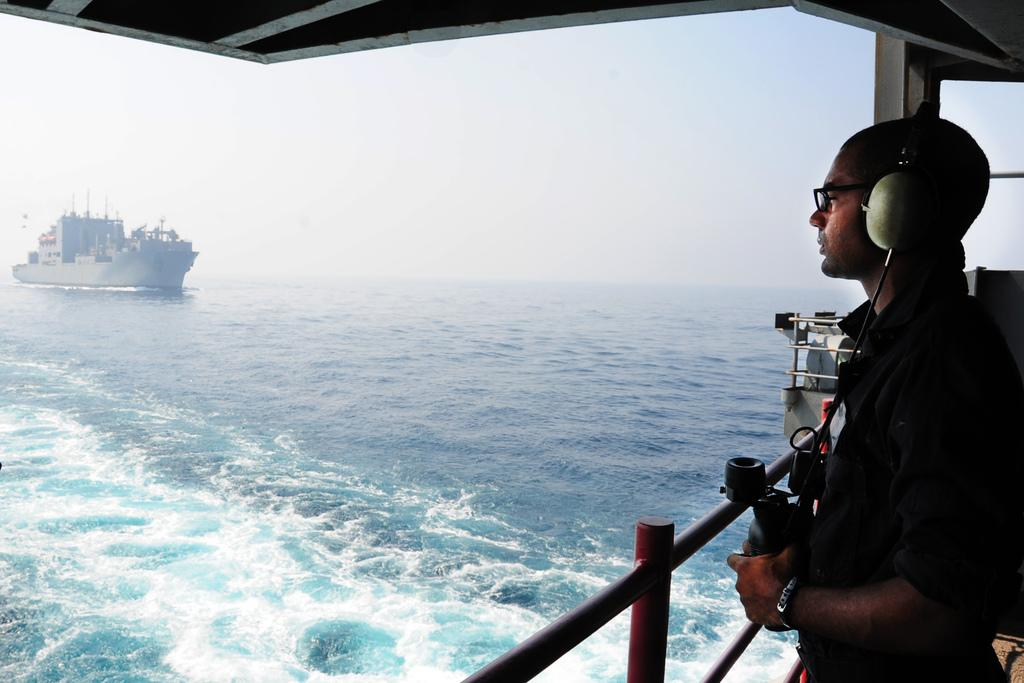What is the person in the image doing? The person is standing in the image. What can be seen on the person's ears? The person is wearing earphones. What is located near the person in the image? There is a ship in the image. What is the ship's location in relation to the water? The ship is on the water. What is the color of the ship? The ship is white in color. What is visible in the background of the image? The sky is visible in the background of the image. What is the color of the sky in the image? The sky appears to be white in color. How many frogs are hopping on the person's shoes in the image? There are no frogs or shoes present in the image, so this question cannot be answered. 